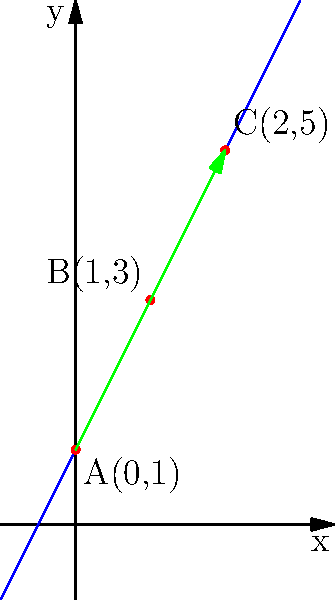A new cyber threat is spreading across networks, and its progression can be modeled on a coordinate plane. The threat's initial detection point is at A(0,1), and subsequent detections are recorded at B(1,3) and C(2,5). If this trend continues linearly, at what point (x,y) will the threat be detected when x = 5? To solve this problem, we need to follow these steps:

1. Recognize the linear pattern: The points A(0,1), B(1,3), and C(2,5) form a straight line, indicating a linear spread of the cyber threat.

2. Calculate the slope of the line:
   Slope = $\frac{y_2 - y_1}{x_2 - x_1} = \frac{5 - 1}{2 - 0} = \frac{4}{2} = 2$

3. Determine the equation of the line:
   Using the point-slope form $y - y_1 = m(x - x_1)$, where m is the slope:
   $y - 1 = 2(x - 0)$
   $y = 2x + 1$

4. Use the equation to find y when x = 5:
   $y = 2(5) + 1 = 10 + 1 = 11$

5. Express the final point:
   When x = 5, y = 11, so the point is (5,11).
Answer: (5,11) 